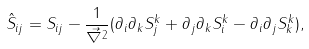Convert formula to latex. <formula><loc_0><loc_0><loc_500><loc_500>\hat { S } _ { i j } = S _ { i j } - \frac { 1 } { \vec { \nabla } ^ { 2 } } ( \partial _ { i } \partial _ { k } S ^ { k } _ { j } + \partial _ { j } \partial _ { k } S ^ { k } _ { i } - \partial _ { i } \partial _ { j } S ^ { k } _ { k } ) ,</formula> 